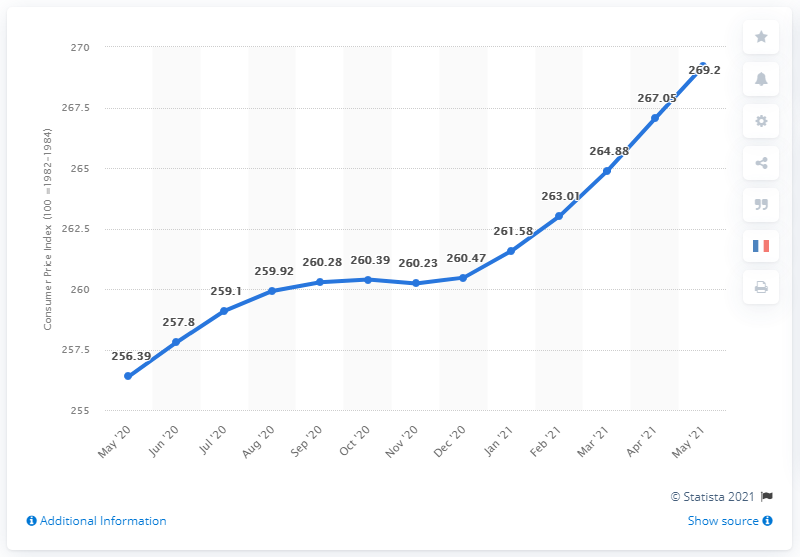Draw attention to some important aspects in this diagram. The difference between the highest and the second highest point is 2.15. In May 2021, the CPI for urban consumers was 269.2, indicating a rate of inflation for urban residents. The number of the highest point is 269.2. 